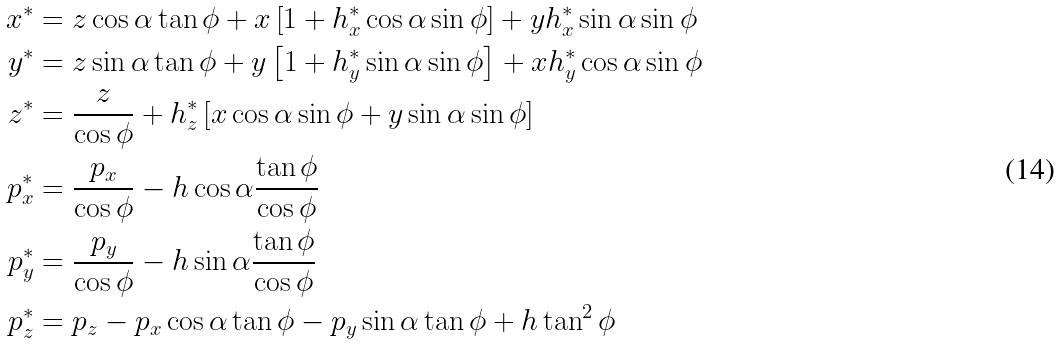Convert formula to latex. <formula><loc_0><loc_0><loc_500><loc_500>x ^ { * } & = z \cos \alpha \tan \phi + x \left [ 1 + h _ { x } ^ { * } \cos \alpha \sin \phi \right ] + y h _ { x } ^ { * } \sin \alpha \sin \phi \\ y ^ { * } & = z \sin \alpha \tan \phi + y \left [ 1 + h _ { y } ^ { * } \sin \alpha \sin \phi \right ] + x h _ { y } ^ { * } \cos \alpha \sin \phi \\ z ^ { * } & = \frac { z } { \cos \phi } + h _ { z } ^ { * } \left [ x \cos \alpha \sin \phi + y \sin \alpha \sin \phi \right ] \\ p _ { x } ^ { * } & = \frac { p _ { x } } { \cos \phi } - h \cos \alpha \frac { \tan \phi } { \cos \phi } \\ p _ { y } ^ { * } & = \frac { p _ { y } } { \cos \phi } - h \sin \alpha \frac { \tan \phi } { \cos \phi } \\ p _ { z } ^ { * } & = p _ { z } - p _ { x } \cos \alpha \tan \phi - p _ { y } \sin \alpha \tan \phi + h \tan ^ { 2 } \phi</formula> 